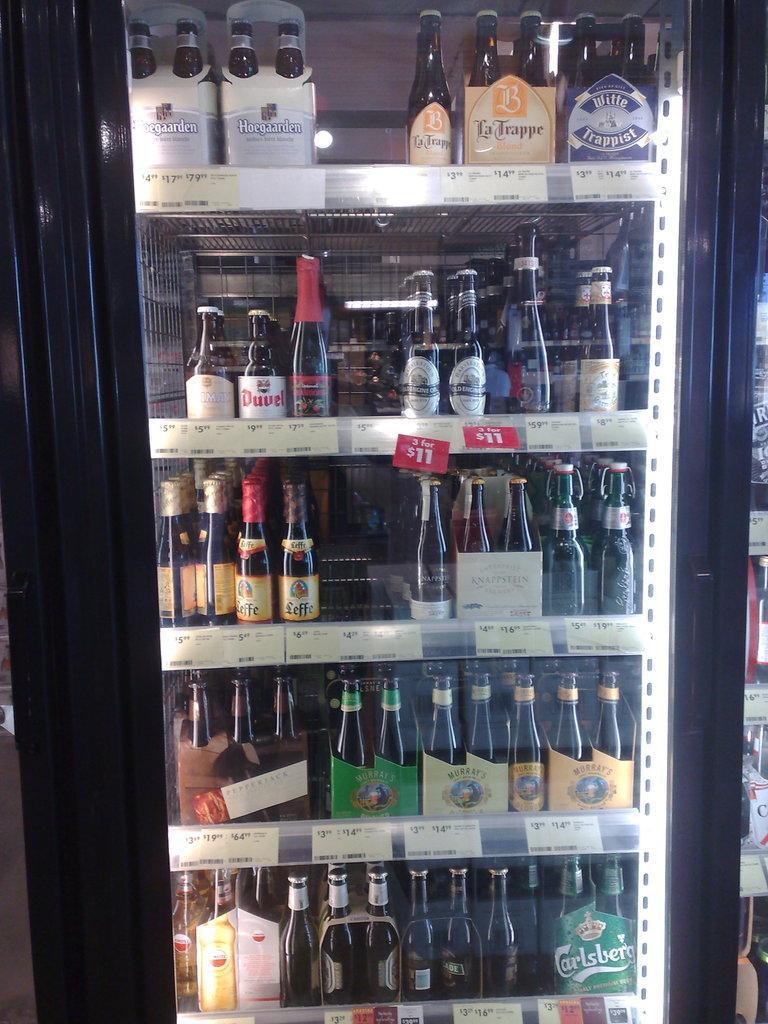Can you describe this image briefly? There is a refrigerator in which some bottles were arranged in the shelves. There are different kinds of bottles. 